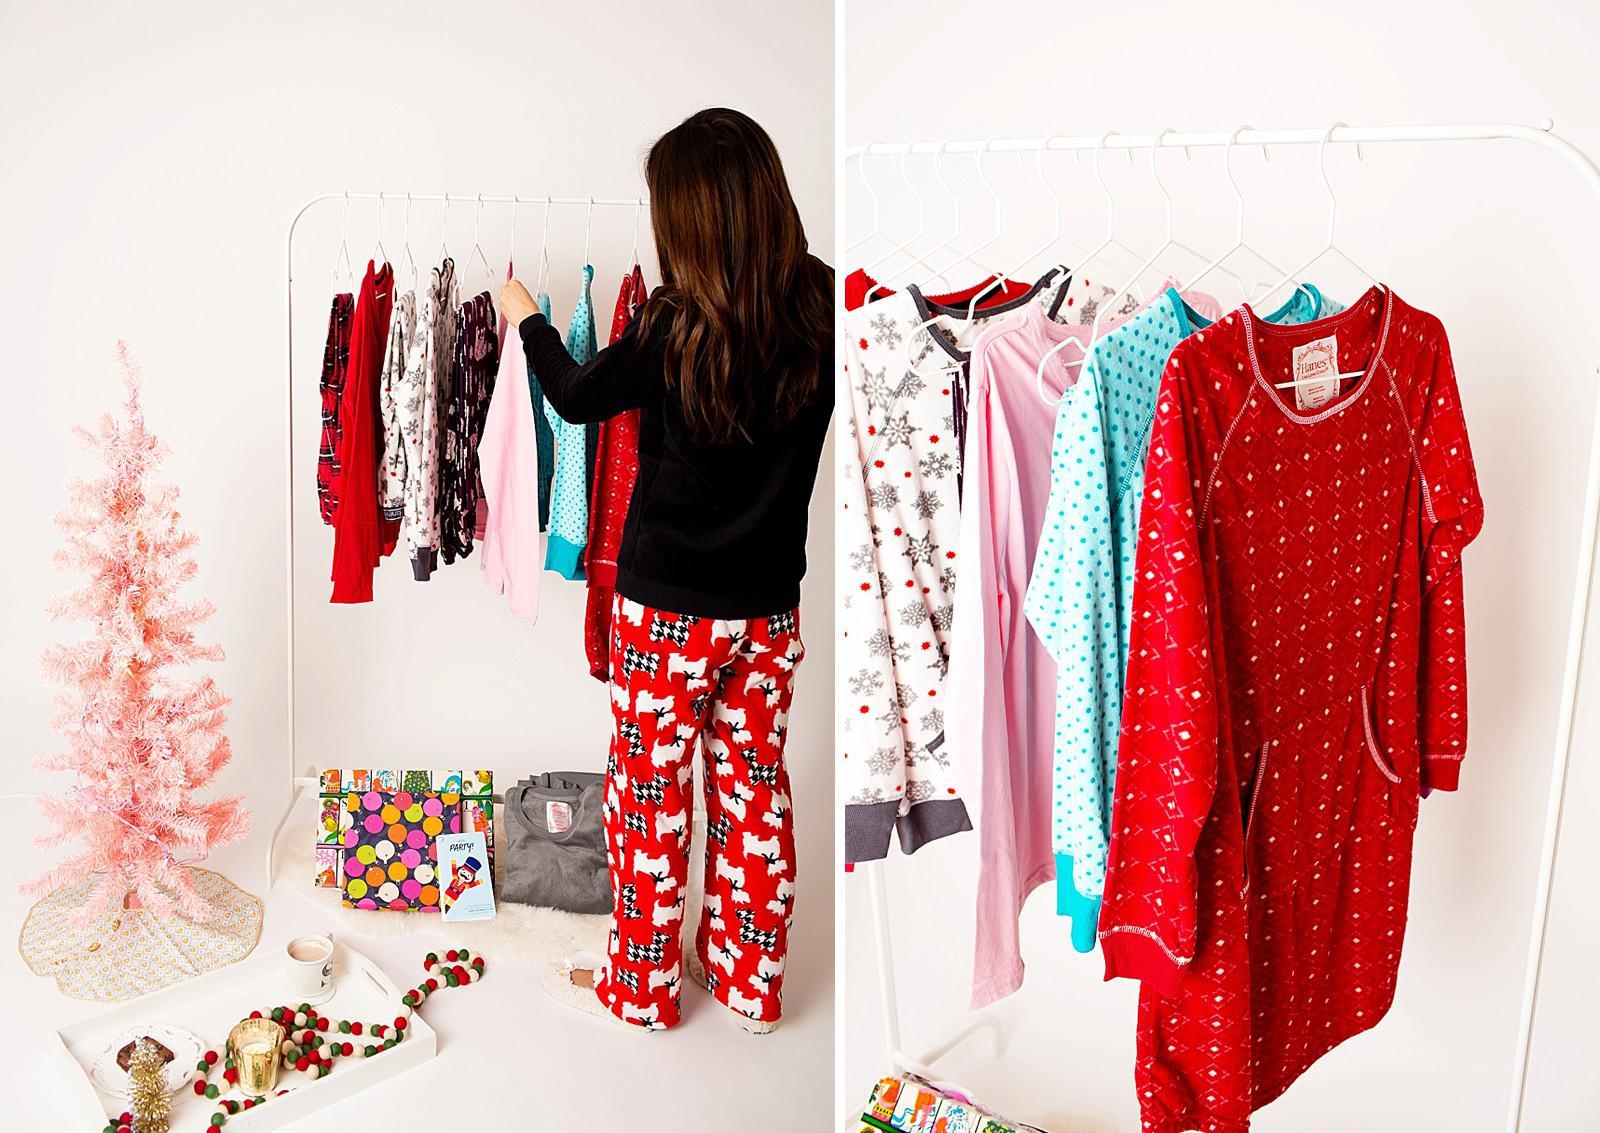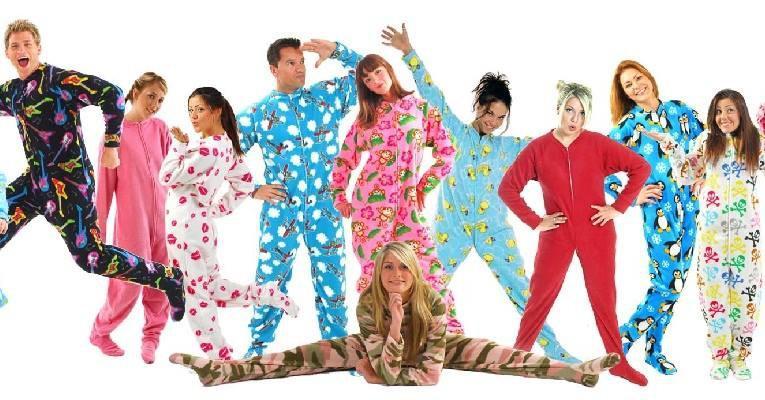The first image is the image on the left, the second image is the image on the right. For the images shown, is this caption "An image shows a woman in printed pj pants sitting in front of a small pink Christmas tree." true? Answer yes or no. No. 